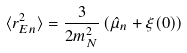Convert formula to latex. <formula><loc_0><loc_0><loc_500><loc_500>\langle r ^ { 2 } _ { E n } \rangle = \frac { 3 } { 2 m _ { N } ^ { 2 } } \, ( \hat { \mu } _ { n } + \xi ( 0 ) )</formula> 